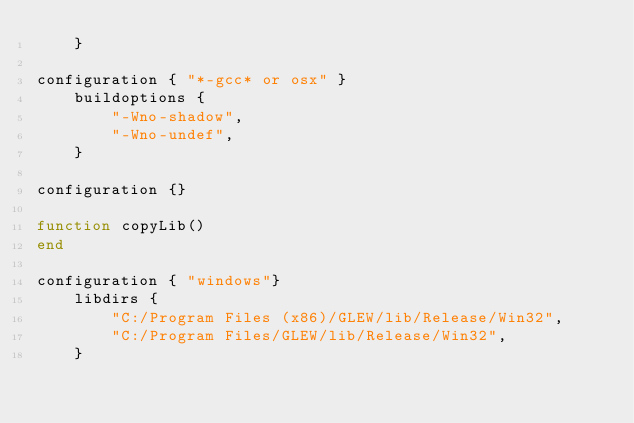Convert code to text. <code><loc_0><loc_0><loc_500><loc_500><_Lua_>    }

configuration { "*-gcc* or osx" }
    buildoptions {
        "-Wno-shadow",
        "-Wno-undef",
    }
        
configuration {}

function copyLib()
end

configuration { "windows"}
    libdirs {
        "C:/Program Files (x86)/GLEW/lib/Release/Win32",
        "C:/Program Files/GLEW/lib/Release/Win32",
    }
    </code> 